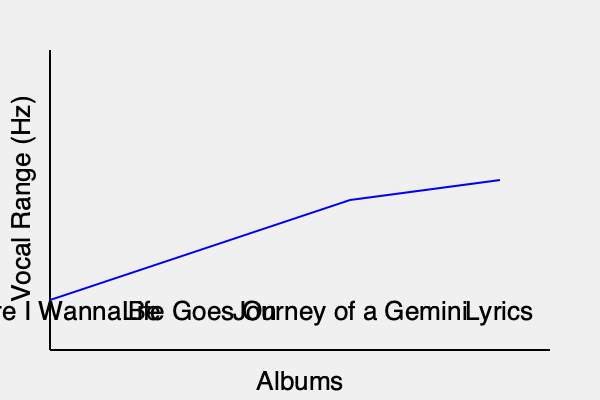Based on the spectrogram visualization of Donell Jones' vocal range across different albums, which trend is observed in his vocal range progression, and what might this suggest about his artistic development? To answer this question, we need to analyze the graph and interpret its implications:

1. Observe the trend: The blue line representing Donell Jones' vocal range shows a gradual increase (moving upwards) from left to right across the albums.

2. Interpret the y-axis: The y-axis represents the vocal range in Hz, with higher values indicating a wider range.

3. Album progression:
   - "Where I Wanna Be" (1999): Lowest point on the graph
   - "Life Goes On" (2002): Slight increase in range
   - "Journey of a Gemini" (2006): Further increase
   - "Lyrics" (2010): Highest point on the graph

4. Calculate the slope: The positive slope indicates an expanding vocal range over time.

5. Artistic development implications:
   - Improved vocal technique: The widening range suggests Jones may have worked on expanding his vocal capabilities.
   - Increased confidence: A broader range might indicate growing comfort with vocal experimentation.
   - Stylistic evolution: The change could reflect a shift in musical style, possibly incorporating more diverse vocal approaches.

6. Consider external factors:
   - Production techniques: Improved recording technology might contribute to capturing a wider range.
   - Song selection: Later albums might feature songs that showcase a broader range.

The trend suggests a consistent expansion of Donell Jones' vocal range across these albums, potentially indicating technical growth, increased artistic confidence, and stylistic evolution in his music career.
Answer: Expanding vocal range, suggesting artistic growth and technical development. 